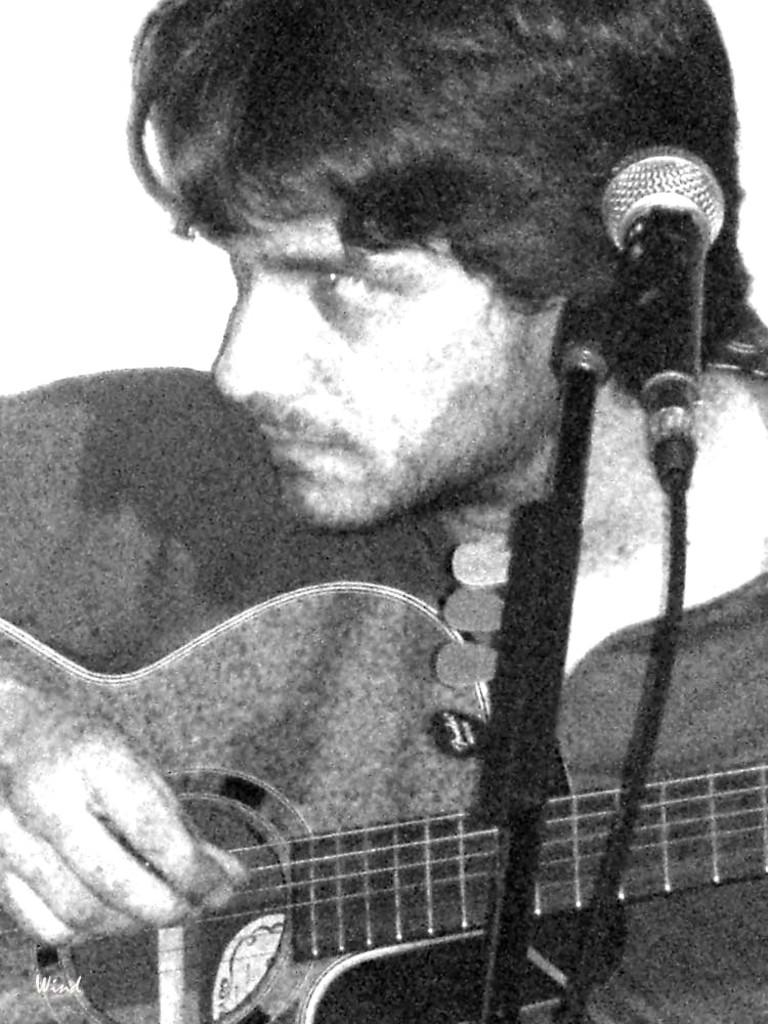What is the color scheme of the image? The image is black and white. Who is present in the image? There is a man in the image. What object is the man standing in front of? The man is in front of a microphone. What is the man doing in the image? The man is playing a guitar. What type of note is the man holding in the image? There is no note visible in the image; the man is playing a guitar. Is the man in the image part of an army? There is no indication in the image that the man is part of an army. 